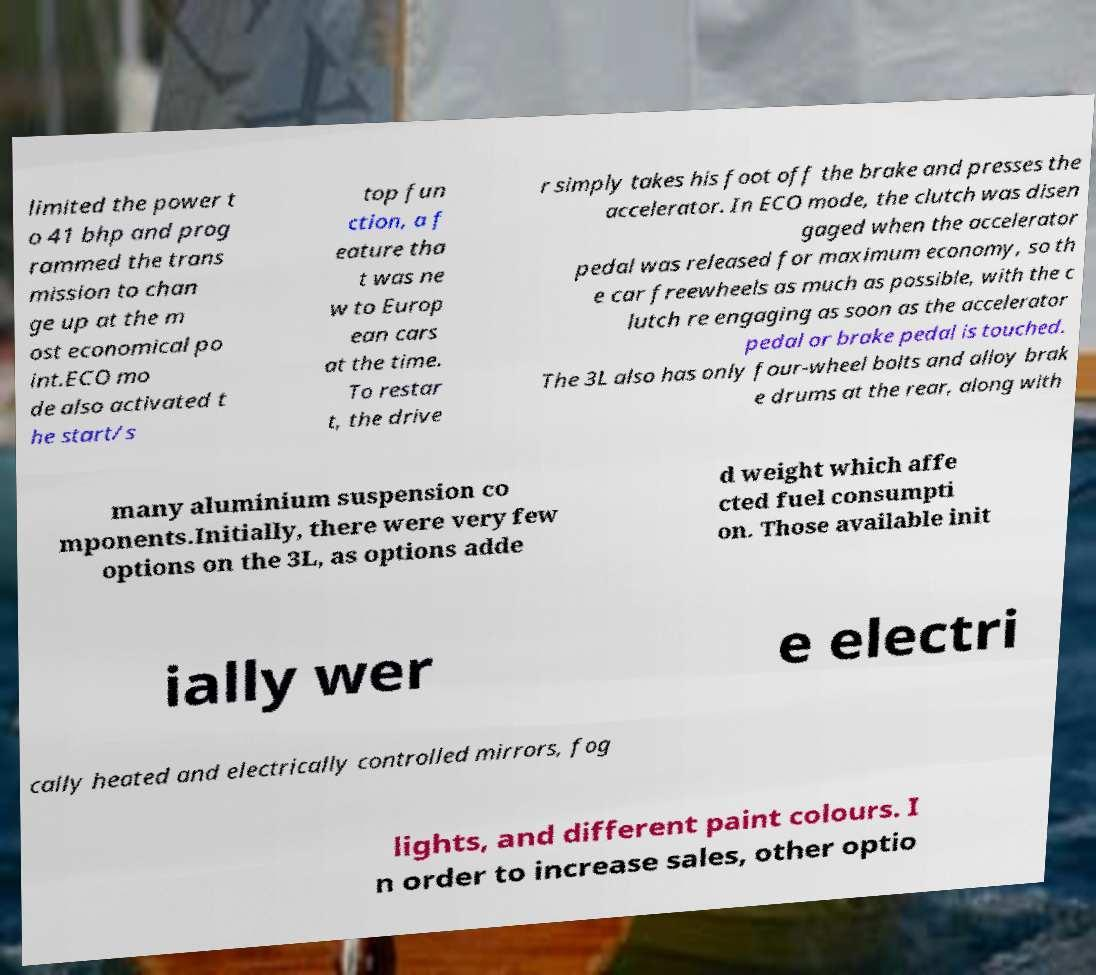What messages or text are displayed in this image? I need them in a readable, typed format. limited the power t o 41 bhp and prog rammed the trans mission to chan ge up at the m ost economical po int.ECO mo de also activated t he start/s top fun ction, a f eature tha t was ne w to Europ ean cars at the time. To restar t, the drive r simply takes his foot off the brake and presses the accelerator. In ECO mode, the clutch was disen gaged when the accelerator pedal was released for maximum economy, so th e car freewheels as much as possible, with the c lutch re engaging as soon as the accelerator pedal or brake pedal is touched. The 3L also has only four-wheel bolts and alloy brak e drums at the rear, along with many aluminium suspension co mponents.Initially, there were very few options on the 3L, as options adde d weight which affe cted fuel consumpti on. Those available init ially wer e electri cally heated and electrically controlled mirrors, fog lights, and different paint colours. I n order to increase sales, other optio 